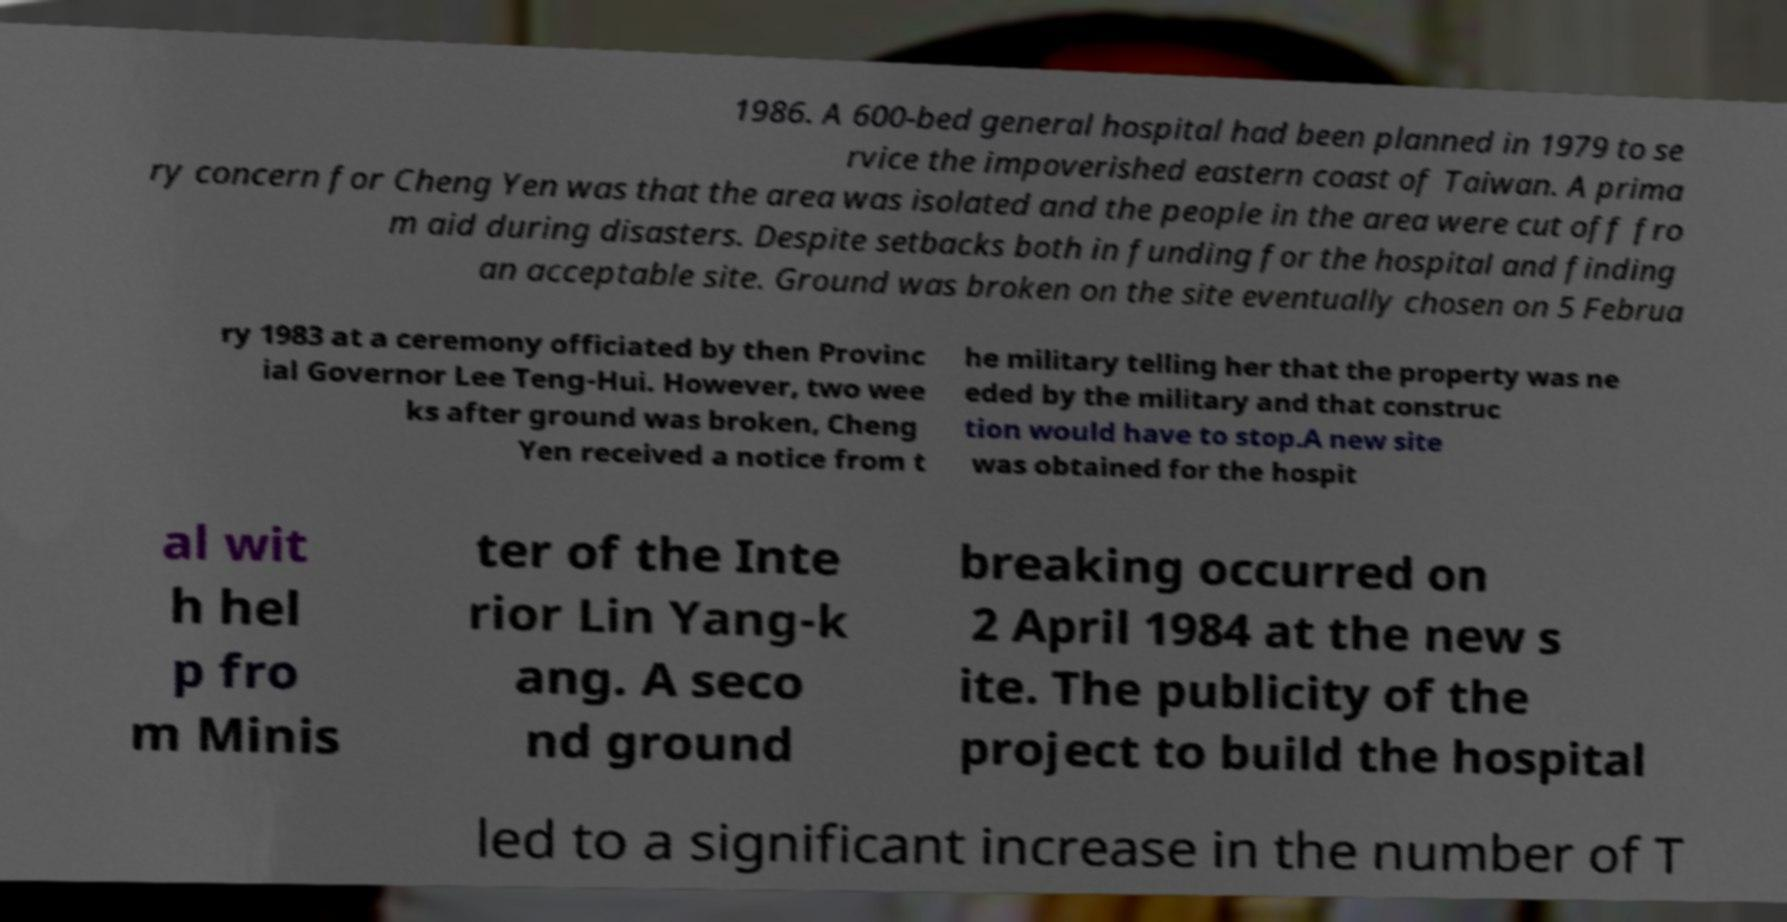I need the written content from this picture converted into text. Can you do that? 1986. A 600-bed general hospital had been planned in 1979 to se rvice the impoverished eastern coast of Taiwan. A prima ry concern for Cheng Yen was that the area was isolated and the people in the area were cut off fro m aid during disasters. Despite setbacks both in funding for the hospital and finding an acceptable site. Ground was broken on the site eventually chosen on 5 Februa ry 1983 at a ceremony officiated by then Provinc ial Governor Lee Teng-Hui. However, two wee ks after ground was broken, Cheng Yen received a notice from t he military telling her that the property was ne eded by the military and that construc tion would have to stop.A new site was obtained for the hospit al wit h hel p fro m Minis ter of the Inte rior Lin Yang-k ang. A seco nd ground breaking occurred on 2 April 1984 at the new s ite. The publicity of the project to build the hospital led to a significant increase in the number of T 